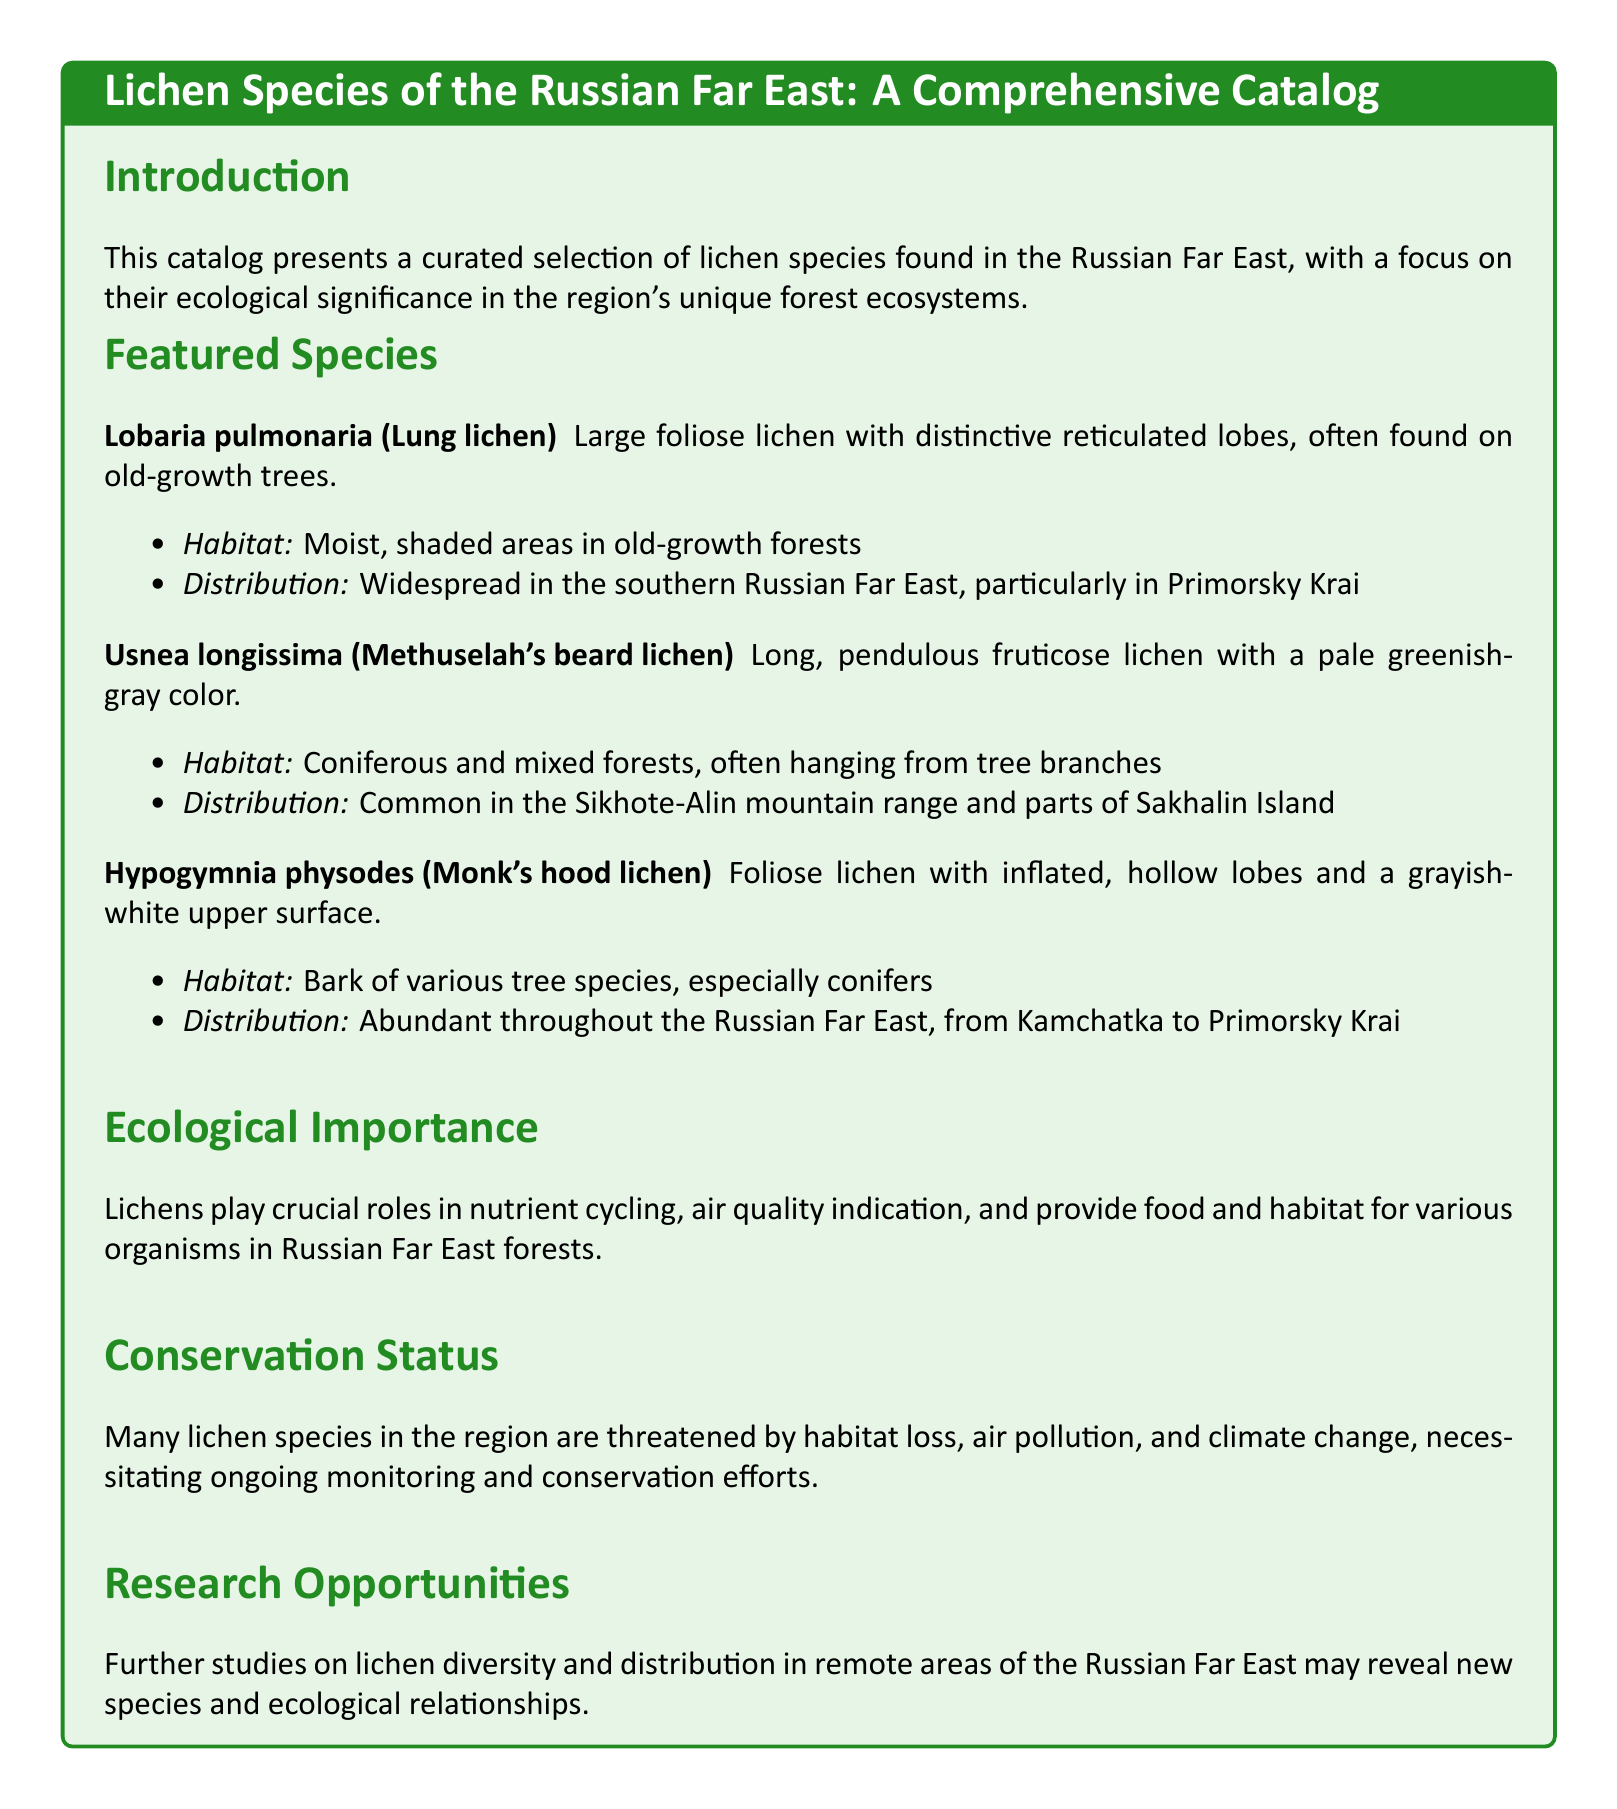What species is known as Lung lichen? The document lists Lobaria pulmonaria as known as Lung lichen.
Answer: Lobaria pulmonaria What habitat does Usnea longissima prefer? The habitat preference for Usnea longissima is mentioned as coniferous and mixed forests.
Answer: Coniferous and mixed forests Which region has abundant Hypogymnia physodes? The document states that Hypogymnia physodes is abundant throughout the Russian Far East.
Answer: Russian Far East What ecological role of lichens is highlighted in the catalog? The document explains lichens play crucial roles in nutrient cycling, air quality indication, and providing food and habitat.
Answer: Nutrient cycling What is threatening many lichen species in the region? The catalog mentions habitat loss, air pollution, and climate change as threats to lichen species.
Answer: Habitat loss, air pollution, and climate change How many featured lichen species are listed in the document? The catalog lists three featured lichen species.
Answer: Three What does the catalog aim to curate? The catalog aims to present a curated selection of lichen species found in the Russian Far East.
Answer: A curated selection of lichen species In which specific geographical area is Lobaria pulmonaria widespread? The document specifies that Lobaria pulmonaria is widespread in the southern Russian Far East.
Answer: Southern Russian Far East What may further studies in the region reveal? The document indicates that further studies may reveal new species and ecological relationships.
Answer: New species and ecological relationships 